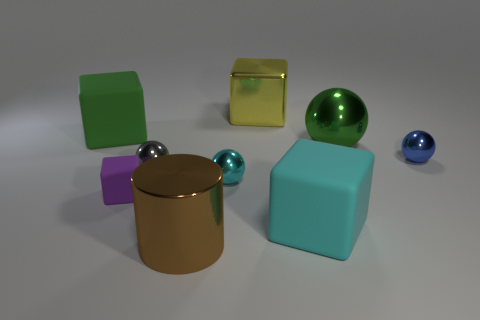Add 1 tiny blue metal objects. How many objects exist? 10 Subtract 1 cyan spheres. How many objects are left? 8 Subtract all cylinders. How many objects are left? 8 Subtract all cyan shiny cylinders. Subtract all big yellow shiny cubes. How many objects are left? 8 Add 1 rubber things. How many rubber things are left? 4 Add 4 purple blocks. How many purple blocks exist? 5 